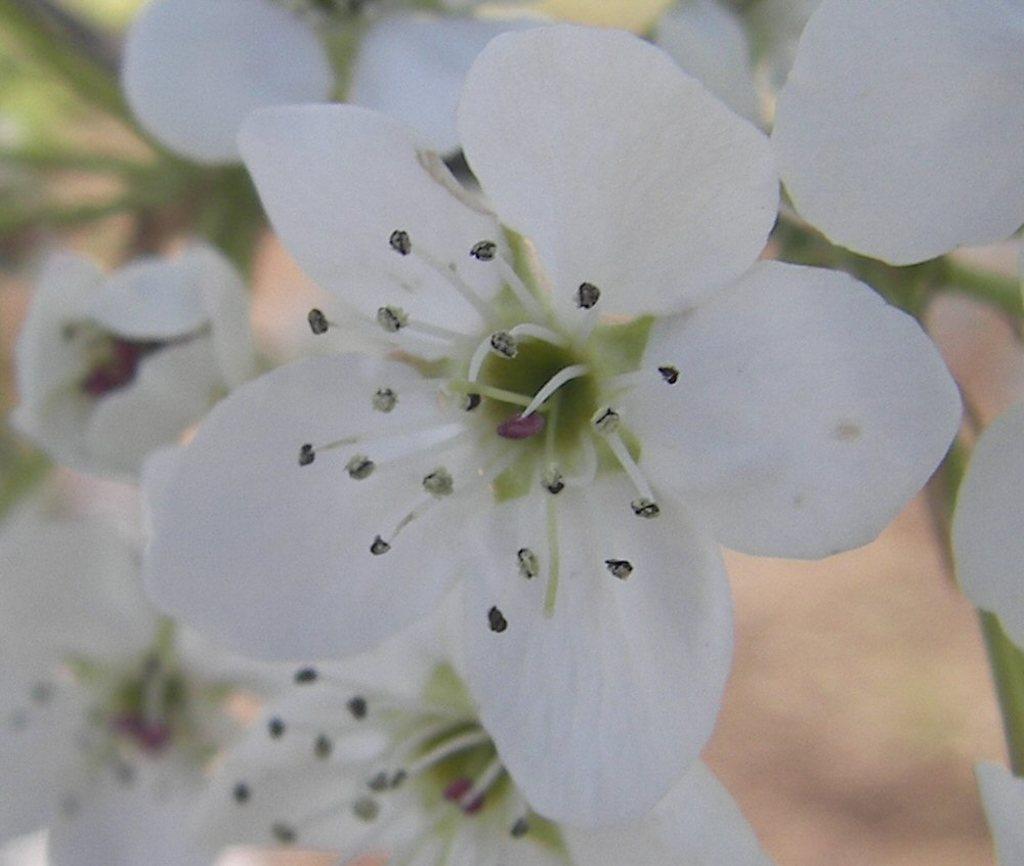Describe this image in one or two sentences. In this image there are white flowers. 